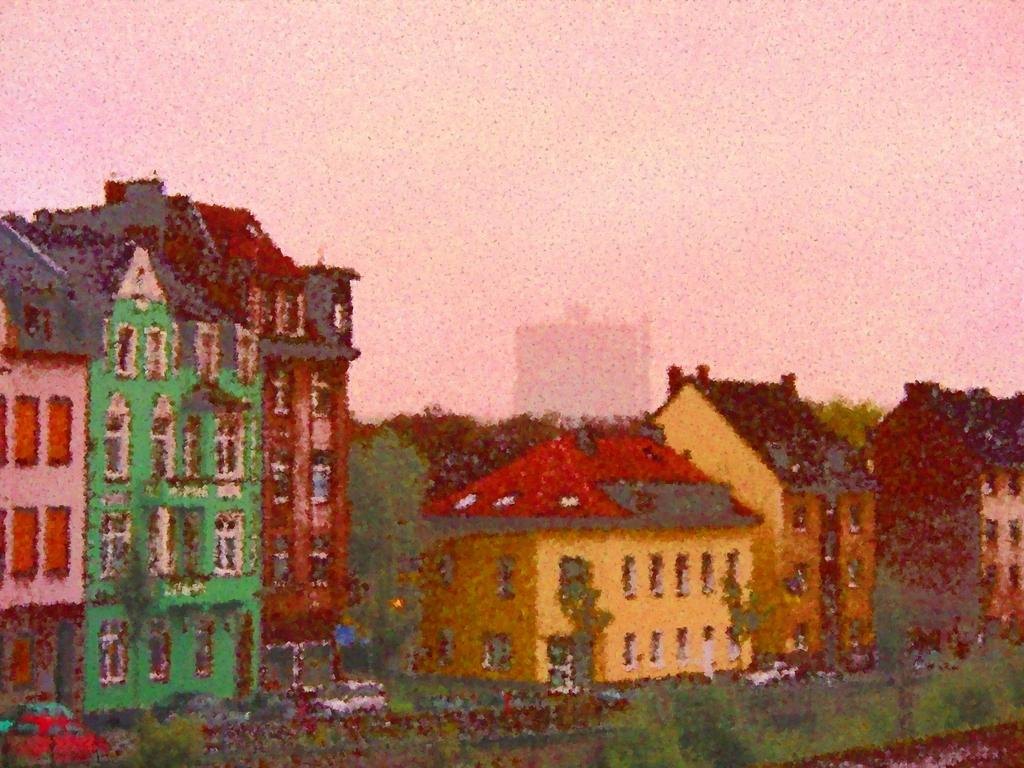What is the main subject of the image? The image contains an art piece. What is depicted in the art piece? The art piece depicts some buildings. What can be seen in the background of the image? There is a sky visible at the top of the image. What type of trail can be seen in the image? There is no trail present in the image; it features an art piece depicting buildings with a sky in the background. 